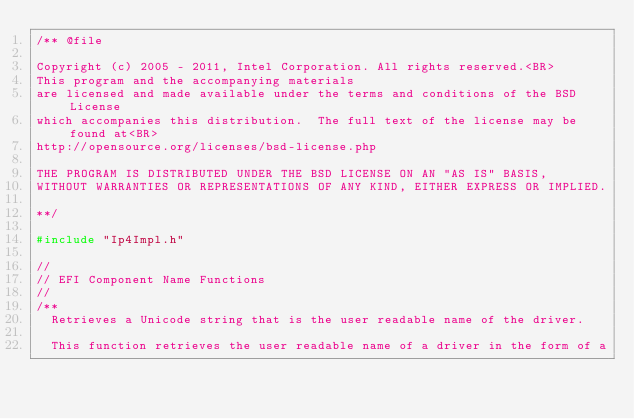Convert code to text. <code><loc_0><loc_0><loc_500><loc_500><_C_>/** @file
  
Copyright (c) 2005 - 2011, Intel Corporation. All rights reserved.<BR>
This program and the accompanying materials
are licensed and made available under the terms and conditions of the BSD License
which accompanies this distribution.  The full text of the license may be found at<BR>
http://opensource.org/licenses/bsd-license.php

THE PROGRAM IS DISTRIBUTED UNDER THE BSD LICENSE ON AN "AS IS" BASIS,
WITHOUT WARRANTIES OR REPRESENTATIONS OF ANY KIND, EITHER EXPRESS OR IMPLIED.

**/

#include "Ip4Impl.h"

//
// EFI Component Name Functions
//
/**
  Retrieves a Unicode string that is the user readable name of the driver.

  This function retrieves the user readable name of a driver in the form of a</code> 